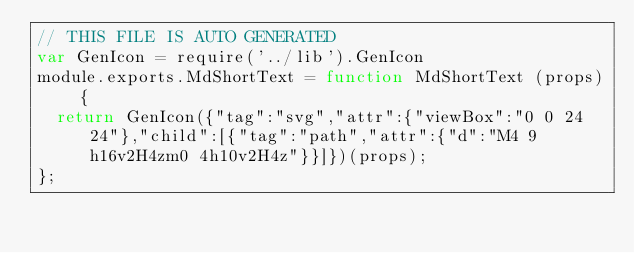Convert code to text. <code><loc_0><loc_0><loc_500><loc_500><_JavaScript_>// THIS FILE IS AUTO GENERATED
var GenIcon = require('../lib').GenIcon
module.exports.MdShortText = function MdShortText (props) {
  return GenIcon({"tag":"svg","attr":{"viewBox":"0 0 24 24"},"child":[{"tag":"path","attr":{"d":"M4 9h16v2H4zm0 4h10v2H4z"}}]})(props);
};
</code> 